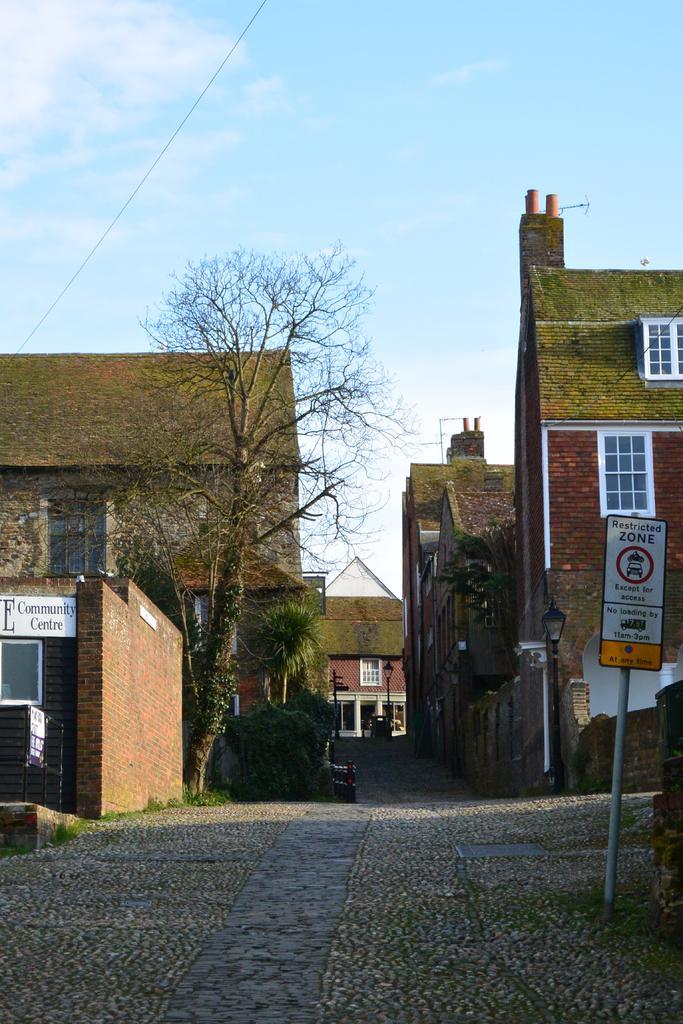Describe this image in one or two sentences. In this image I can see buildings. There are name boards, lights, trees, brick walls and in the background there is sky. 